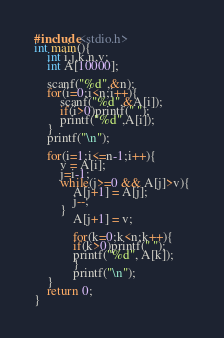<code> <loc_0><loc_0><loc_500><loc_500><_C_>#include<stdio.h>
int main(){
    int i,j,k,n,v;
    int A[10000];

    scanf("%d",&n);
    for(i=0;i<n;i++){
        scanf("%d",&A[i]);
        if(i>0)printf(" ");
        printf("%d",A[i]);
    }
    printf("\n");
   
    for(i=1;i<=n-1;i++){
        v = A[i];
        j=i-1;
        while(j>=0 && A[j]>v){
            A[j+1] = A[j];
            j--;
        }
            A[j+1] = v;

            for(k=0;k<n;k++){
            if(k>0)printf(" ");
            printf("%d", A[k]);
            }
            printf("\n");
    }
    return 0;
}
</code> 